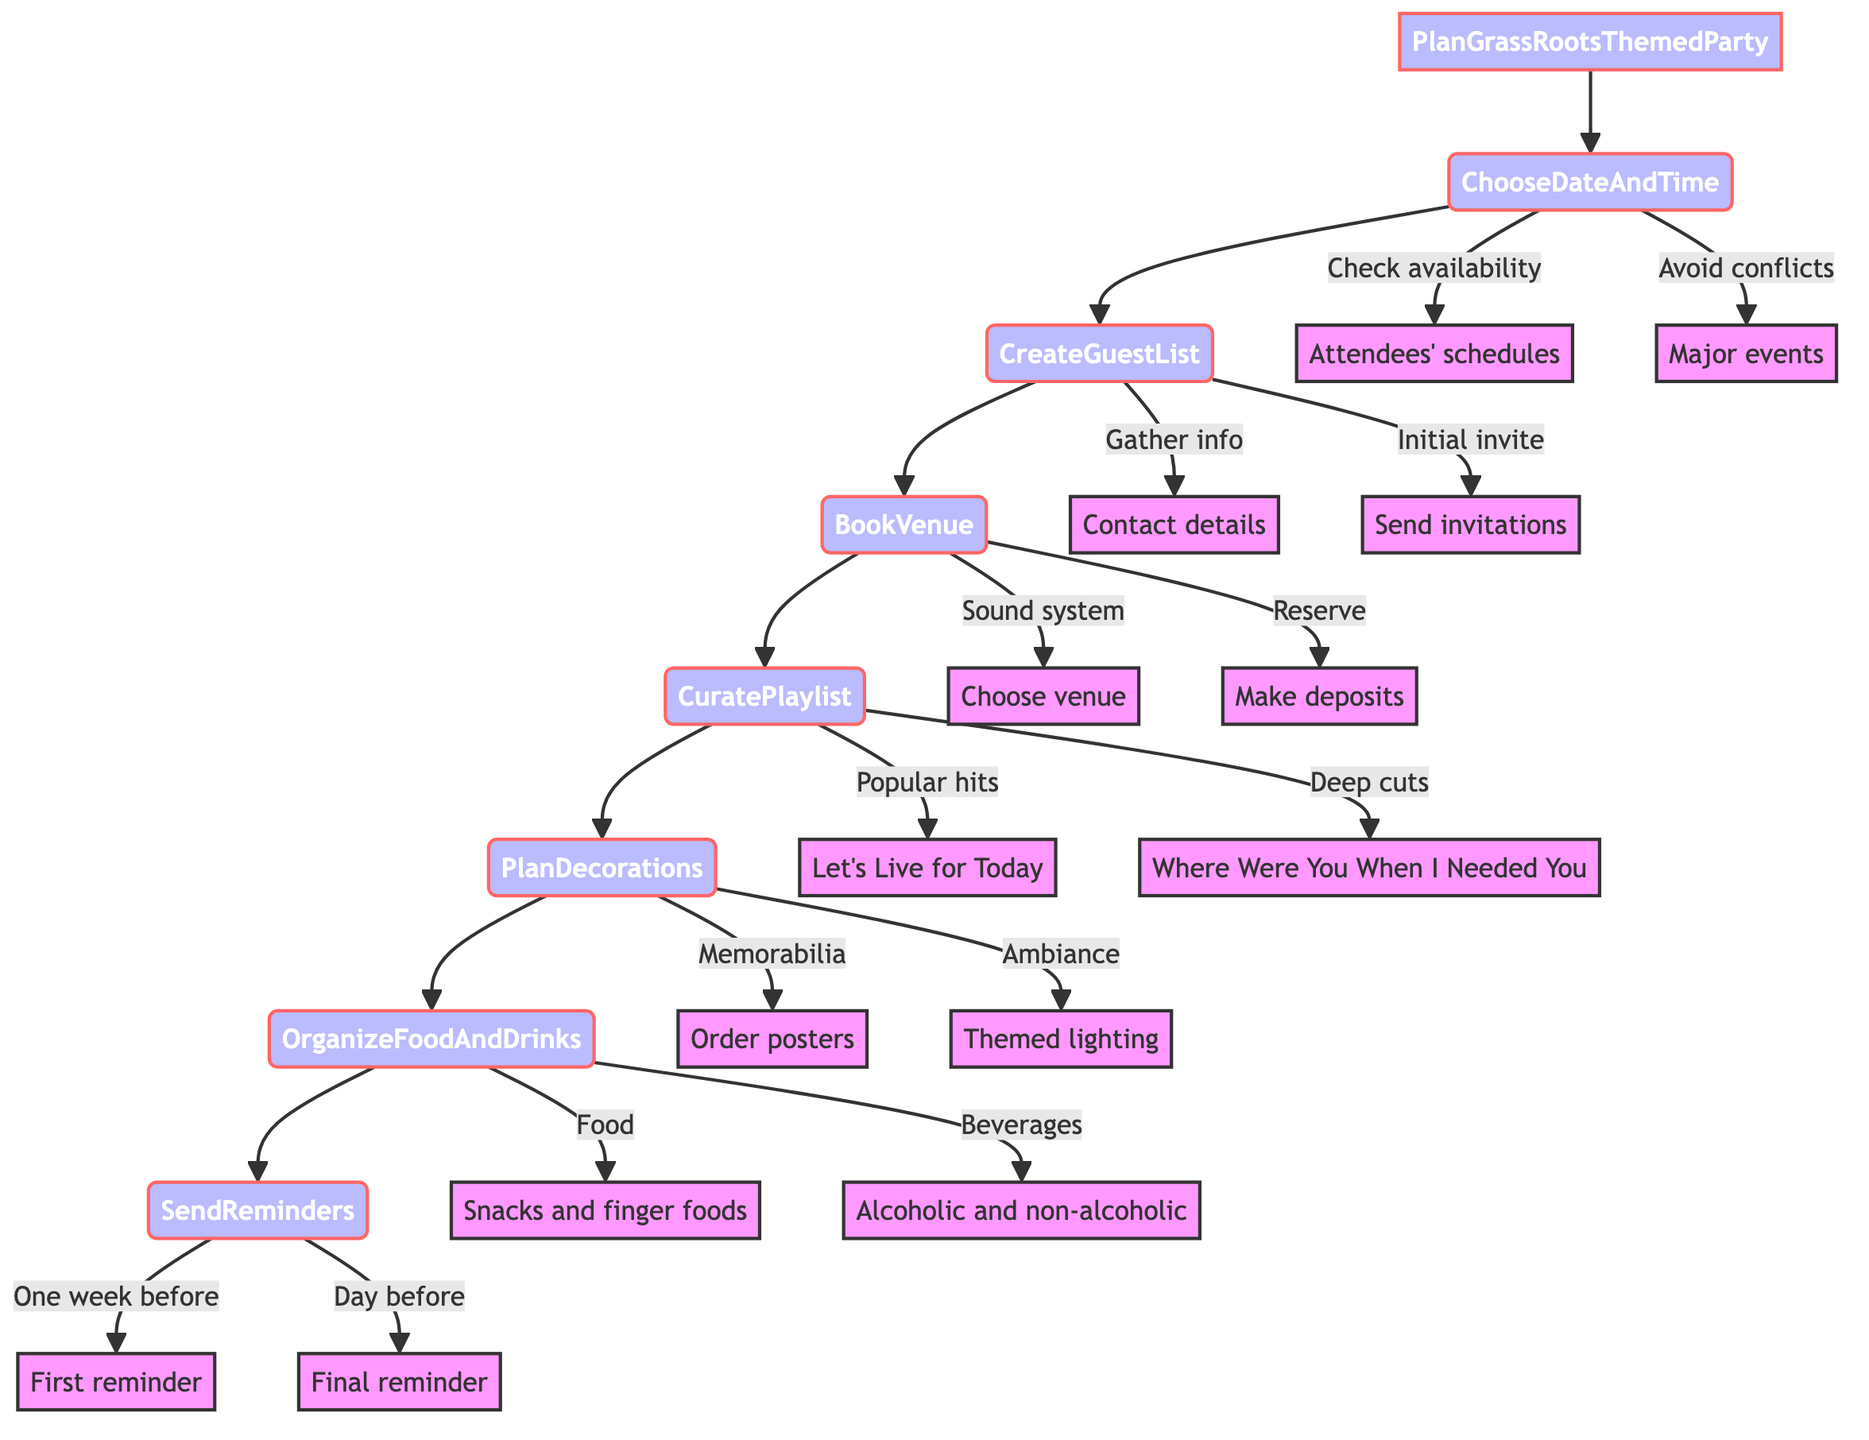What is the first step in planning the party? The diagram indicates that the first step is "ChooseDateAndTime". This step is directly connected to the "PlanGrassRootsThemedParty" node, making it the starting point of the flowchart.
Answer: ChooseDateAndTime How many main steps are there in the planning process? The flowchart shows a total of 7 main steps leading from "PlanGrassRootsThemedParty" to "SendReminders". These steps are sequentially connected and represent the entire planning process.
Answer: 7 What type of venue should be chosen? According to the diagram, the step "BookVenue" includes the action to "Choose a venue with good sound system", indicating that the venue should support good sound quality for the party.
Answer: Good sound system What is sent one week before the party? The "SendReminders" step indicates that a "First reminder" is sent one week before the party, providing advance notice to the guests.
Answer: First reminder Which item is included in the food preparation? In the "OrganizeFoodAndDrinks" step, it specifies that the menu should include "snacks and finger foods", indicating these are key refreshments for the party.
Answer: Snacks and finger foods What is a part of the playlist curation? The "CuratePlaylist" step lists actions such as including "Let's Live for Today", which is one of the popular hits to be added to the playlist for the party.
Answer: Let's Live for Today Explain the sequence from creating the guest list to sending reminders. The steps show that after "CreateGuestList", the next step is "BookVenue", followed by "CuratePlaylist", "PlanDecorations", "OrganizeFoodAndDrinks", and finally "SendReminders". This sequence indicates that after inviting guests, the venue and party details are organized before final reminders are sent out as the party date approaches.
Answer: CreateGuestList to SendReminders What action is paired with choosing a venue? The "BookVenue" step includes the action "Make necessary deposits" alongside choosing the venue, meaning financial commitments must be made to secure the location.
Answer: Make necessary deposits 